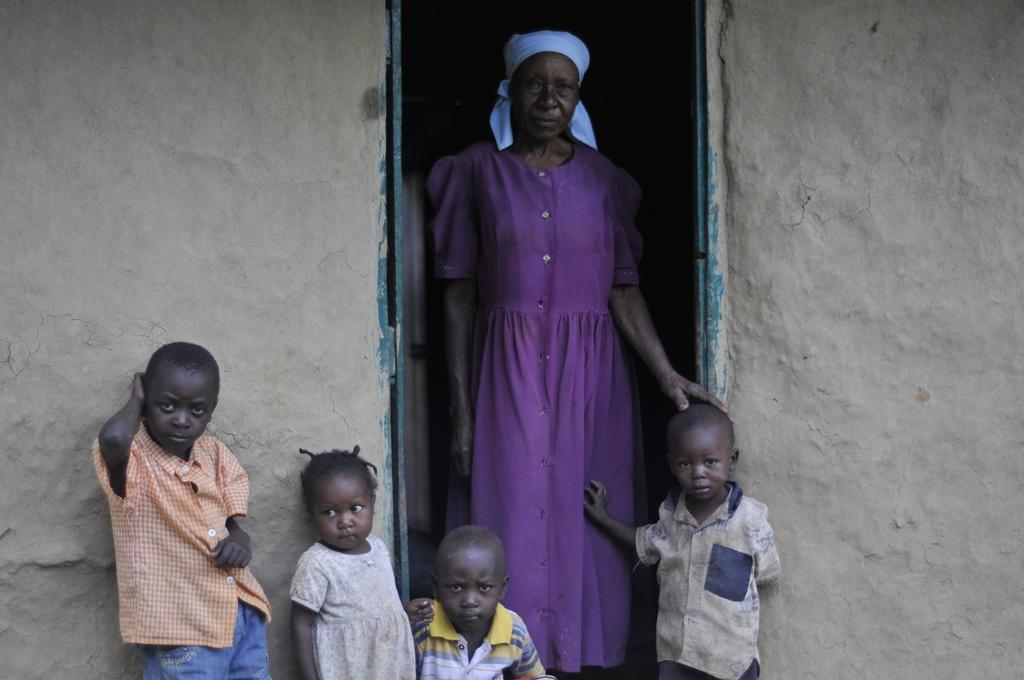What is the main subject in the center of the image? There is a woman standing in the center of the image. Are there any other people in the image besides the woman? Yes, there are children in the image. What type of structure can be seen in the background? There is a house in the image. What type of fuel is being used by the soda in the image? There is no soda present in the image, so it is not possible to determine what type of fuel it might use. 